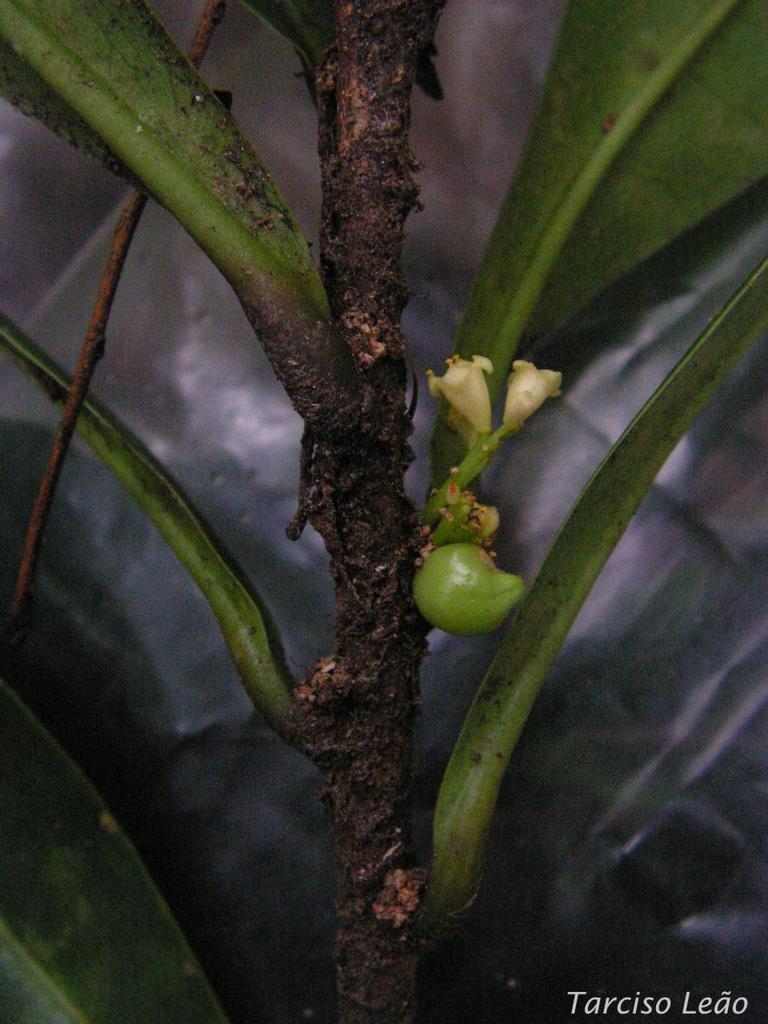Can you describe this image briefly? In this picture I can see there is a plant and it has few leaves and there are flowers and fruits to it. There is something written at the right bottom of the picture and the backdrop is blurred. 